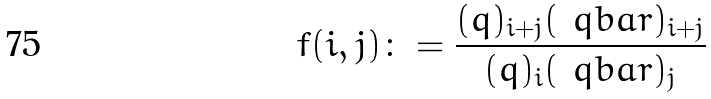Convert formula to latex. <formula><loc_0><loc_0><loc_500><loc_500>f ( i , j ) \colon = \frac { ( q ) _ { i + j } ( \ q b a r ) _ { i + j } } { ( q ) _ { i } ( \ q b a r ) _ { j } }</formula> 